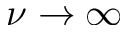Convert formula to latex. <formula><loc_0><loc_0><loc_500><loc_500>\nu \to \infty</formula> 